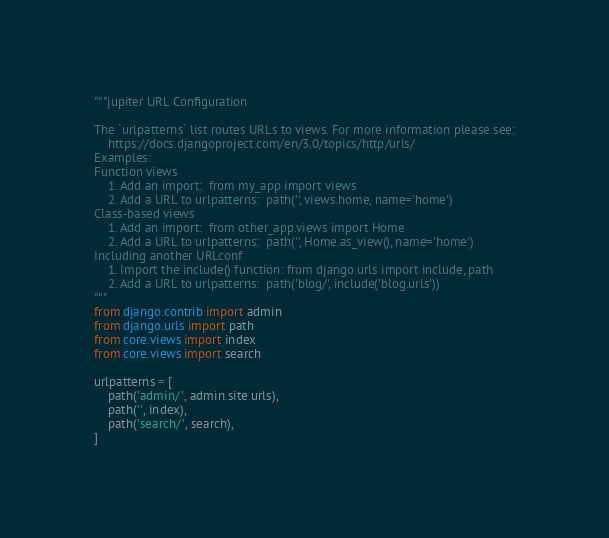Convert code to text. <code><loc_0><loc_0><loc_500><loc_500><_Python_>"""jupiter URL Configuration

The `urlpatterns` list routes URLs to views. For more information please see:
    https://docs.djangoproject.com/en/3.0/topics/http/urls/
Examples:
Function views
    1. Add an import:  from my_app import views
    2. Add a URL to urlpatterns:  path('', views.home, name='home')
Class-based views
    1. Add an import:  from other_app.views import Home
    2. Add a URL to urlpatterns:  path('', Home.as_view(), name='home')
Including another URLconf
    1. Import the include() function: from django.urls import include, path
    2. Add a URL to urlpatterns:  path('blog/', include('blog.urls'))
"""
from django.contrib import admin
from django.urls import path
from core.views import index
from core.views import search

urlpatterns = [
    path('admin/', admin.site.urls),
    path('', index),
    path('search/', search),
]
</code> 